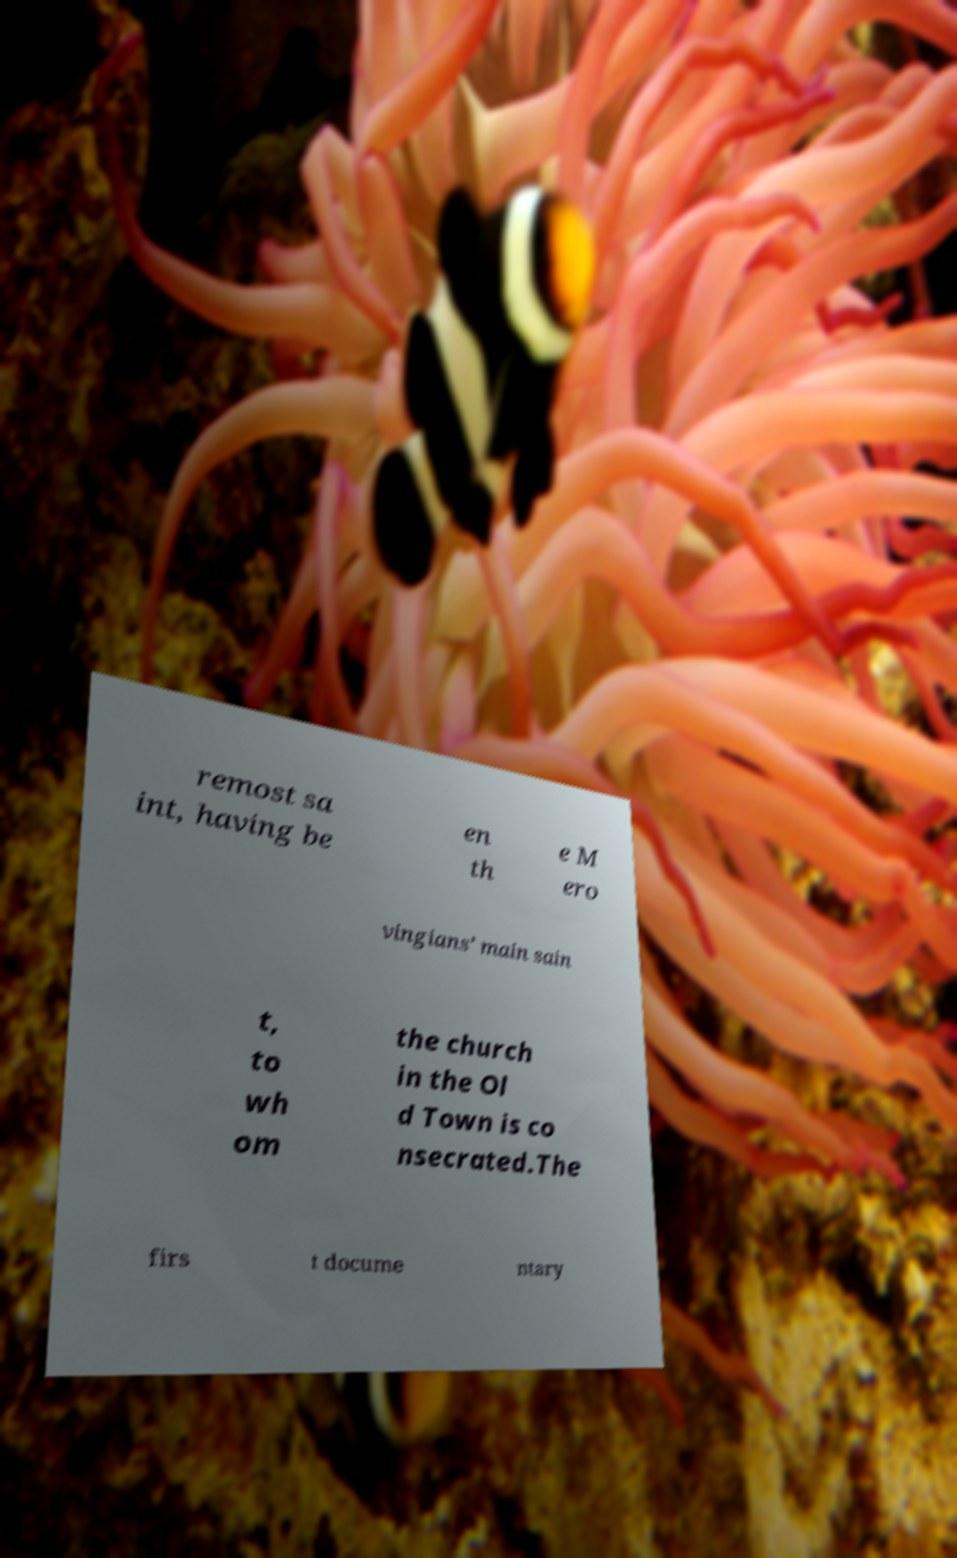Please identify and transcribe the text found in this image. remost sa int, having be en th e M ero vingians’ main sain t, to wh om the church in the Ol d Town is co nsecrated.The firs t docume ntary 